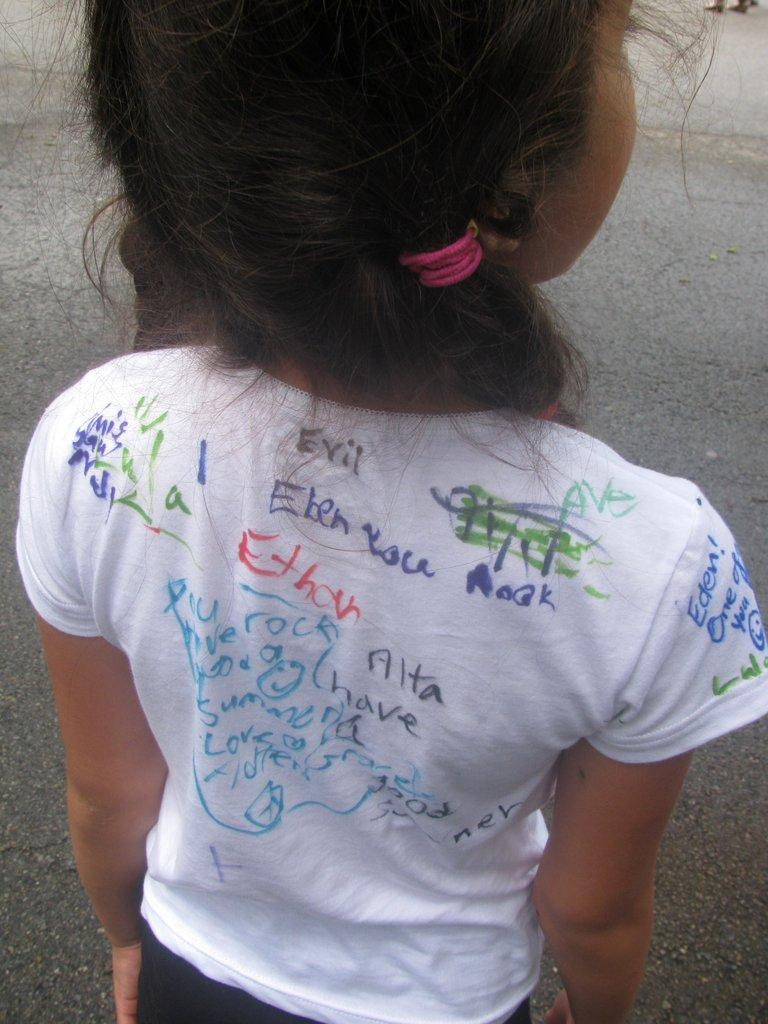Who is the main subject in the picture? There is a girl in the picture. What is the girl doing in the image? The girl is standing. What is the girl wearing in the picture? The girl is wearing a white t-shirt. Can you describe the t-shirt further? Yes, there is writing on the girl's t-shirt. What can be seen in the background of the picture? There is a road in the background of the picture. Where is the throne located in the image? There is no throne present in the image. What type of mailbox can be seen near the girl in the image? There is no mailbox present in the image. 